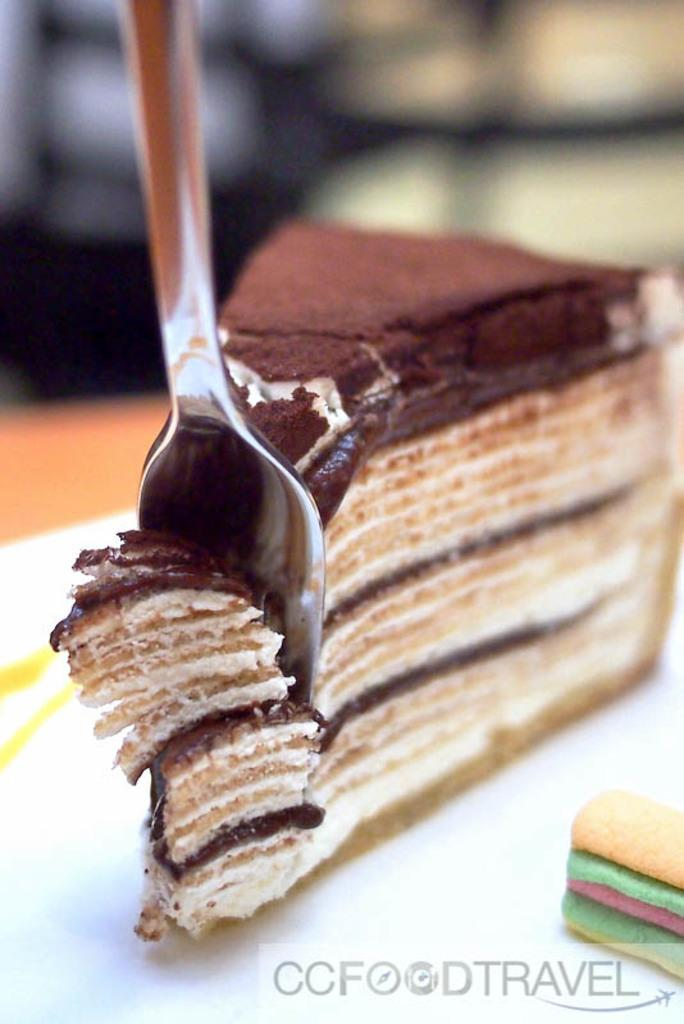What is the main food item visible in the image? There is a piece of cake in the image. What utensil is placed on the plate in the image? There is a spoon placed on the plate in the image. What can be seen at the bottom of the image? There is some food visible at the bottom of the image, along with text. Where is the notebook stored in the image? There is no notebook present in the image. Can you describe the self in the image? There is no self or person present in the image; it only shows a piece of cake, a spoon, and some food and text at the bottom. 